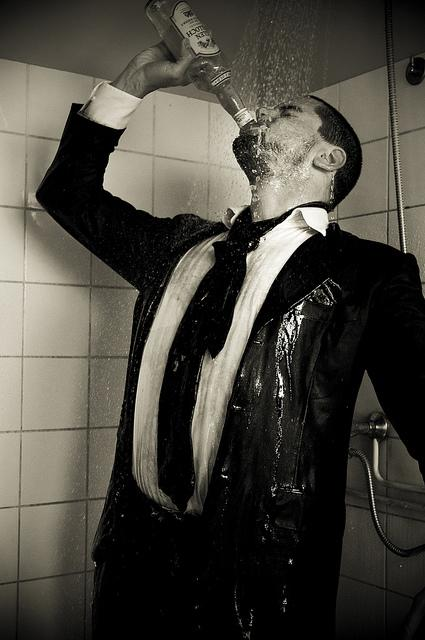What single item is most out of place? shower 